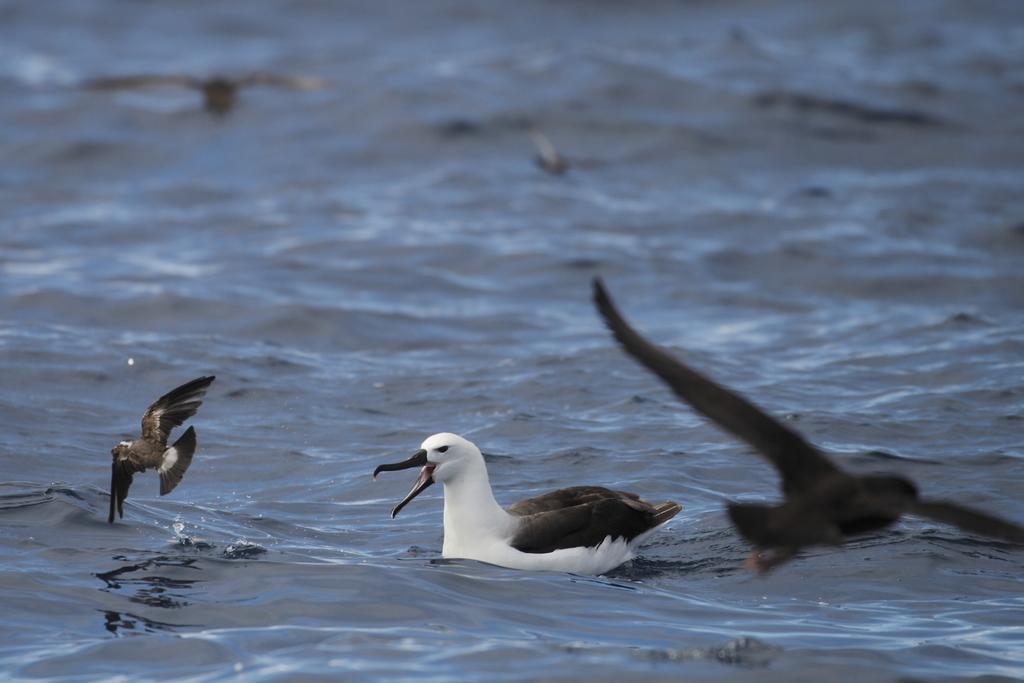How would you summarize this image in a sentence or two? In the foreground of this image, there is a bird on the water and few birds in the air above the water surface. 